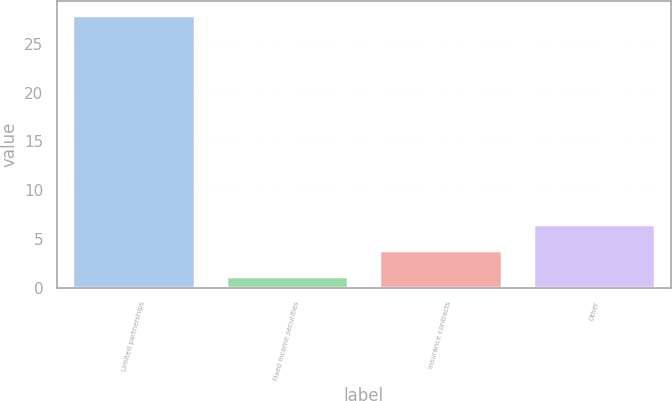Convert chart to OTSL. <chart><loc_0><loc_0><loc_500><loc_500><bar_chart><fcel>Limited partnerships<fcel>Fixed income securities<fcel>Insurance contracts<fcel>Other<nl><fcel>28<fcel>1.19<fcel>3.87<fcel>6.55<nl></chart> 